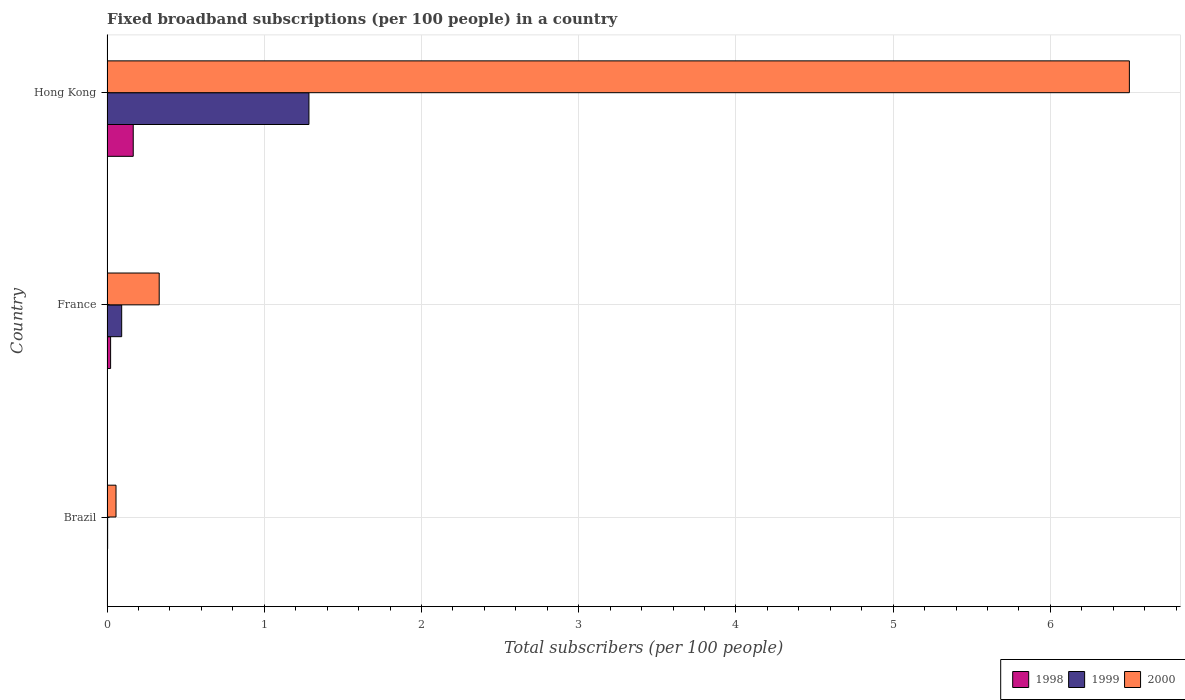Are the number of bars on each tick of the Y-axis equal?
Ensure brevity in your answer.  Yes. In how many cases, is the number of bars for a given country not equal to the number of legend labels?
Make the answer very short. 0. What is the number of broadband subscriptions in 2000 in France?
Make the answer very short. 0.33. Across all countries, what is the maximum number of broadband subscriptions in 1998?
Provide a succinct answer. 0.17. Across all countries, what is the minimum number of broadband subscriptions in 2000?
Provide a short and direct response. 0.06. In which country was the number of broadband subscriptions in 1999 maximum?
Your response must be concise. Hong Kong. In which country was the number of broadband subscriptions in 2000 minimum?
Your answer should be very brief. Brazil. What is the total number of broadband subscriptions in 1998 in the graph?
Your answer should be compact. 0.19. What is the difference between the number of broadband subscriptions in 1998 in France and that in Hong Kong?
Make the answer very short. -0.14. What is the difference between the number of broadband subscriptions in 2000 in Hong Kong and the number of broadband subscriptions in 1998 in France?
Your response must be concise. 6.48. What is the average number of broadband subscriptions in 1998 per country?
Make the answer very short. 0.06. What is the difference between the number of broadband subscriptions in 1998 and number of broadband subscriptions in 2000 in Hong Kong?
Your response must be concise. -6.34. In how many countries, is the number of broadband subscriptions in 1998 greater than 6 ?
Give a very brief answer. 0. What is the ratio of the number of broadband subscriptions in 1999 in Brazil to that in Hong Kong?
Give a very brief answer. 0. Is the number of broadband subscriptions in 1999 in Brazil less than that in Hong Kong?
Offer a very short reply. Yes. Is the difference between the number of broadband subscriptions in 1998 in Brazil and Hong Kong greater than the difference between the number of broadband subscriptions in 2000 in Brazil and Hong Kong?
Keep it short and to the point. Yes. What is the difference between the highest and the second highest number of broadband subscriptions in 2000?
Your answer should be very brief. 6.17. What is the difference between the highest and the lowest number of broadband subscriptions in 1998?
Your answer should be very brief. 0.17. Is the sum of the number of broadband subscriptions in 1998 in Brazil and France greater than the maximum number of broadband subscriptions in 2000 across all countries?
Your answer should be very brief. No. What does the 1st bar from the top in France represents?
Your answer should be very brief. 2000. What does the 3rd bar from the bottom in Hong Kong represents?
Offer a terse response. 2000. Is it the case that in every country, the sum of the number of broadband subscriptions in 1999 and number of broadband subscriptions in 2000 is greater than the number of broadband subscriptions in 1998?
Provide a succinct answer. Yes. Does the graph contain any zero values?
Your answer should be compact. No. Does the graph contain grids?
Provide a short and direct response. Yes. How many legend labels are there?
Offer a very short reply. 3. What is the title of the graph?
Keep it short and to the point. Fixed broadband subscriptions (per 100 people) in a country. What is the label or title of the X-axis?
Provide a succinct answer. Total subscribers (per 100 people). What is the label or title of the Y-axis?
Offer a very short reply. Country. What is the Total subscribers (per 100 people) in 1998 in Brazil?
Provide a short and direct response. 0. What is the Total subscribers (per 100 people) of 1999 in Brazil?
Keep it short and to the point. 0. What is the Total subscribers (per 100 people) of 2000 in Brazil?
Ensure brevity in your answer.  0.06. What is the Total subscribers (per 100 people) in 1998 in France?
Your response must be concise. 0.02. What is the Total subscribers (per 100 people) of 1999 in France?
Ensure brevity in your answer.  0.09. What is the Total subscribers (per 100 people) in 2000 in France?
Your response must be concise. 0.33. What is the Total subscribers (per 100 people) of 1998 in Hong Kong?
Give a very brief answer. 0.17. What is the Total subscribers (per 100 people) in 1999 in Hong Kong?
Provide a short and direct response. 1.28. What is the Total subscribers (per 100 people) of 2000 in Hong Kong?
Ensure brevity in your answer.  6.5. Across all countries, what is the maximum Total subscribers (per 100 people) of 1998?
Give a very brief answer. 0.17. Across all countries, what is the maximum Total subscribers (per 100 people) of 1999?
Offer a very short reply. 1.28. Across all countries, what is the maximum Total subscribers (per 100 people) of 2000?
Ensure brevity in your answer.  6.5. Across all countries, what is the minimum Total subscribers (per 100 people) of 1998?
Offer a terse response. 0. Across all countries, what is the minimum Total subscribers (per 100 people) of 1999?
Ensure brevity in your answer.  0. Across all countries, what is the minimum Total subscribers (per 100 people) in 2000?
Offer a terse response. 0.06. What is the total Total subscribers (per 100 people) in 1998 in the graph?
Ensure brevity in your answer.  0.19. What is the total Total subscribers (per 100 people) of 1999 in the graph?
Provide a succinct answer. 1.38. What is the total Total subscribers (per 100 people) in 2000 in the graph?
Make the answer very short. 6.89. What is the difference between the Total subscribers (per 100 people) of 1998 in Brazil and that in France?
Make the answer very short. -0.02. What is the difference between the Total subscribers (per 100 people) of 1999 in Brazil and that in France?
Provide a succinct answer. -0.09. What is the difference between the Total subscribers (per 100 people) in 2000 in Brazil and that in France?
Your response must be concise. -0.27. What is the difference between the Total subscribers (per 100 people) of 1998 in Brazil and that in Hong Kong?
Your answer should be very brief. -0.17. What is the difference between the Total subscribers (per 100 people) of 1999 in Brazil and that in Hong Kong?
Offer a terse response. -1.28. What is the difference between the Total subscribers (per 100 people) of 2000 in Brazil and that in Hong Kong?
Your answer should be very brief. -6.45. What is the difference between the Total subscribers (per 100 people) of 1998 in France and that in Hong Kong?
Make the answer very short. -0.14. What is the difference between the Total subscribers (per 100 people) of 1999 in France and that in Hong Kong?
Your response must be concise. -1.19. What is the difference between the Total subscribers (per 100 people) in 2000 in France and that in Hong Kong?
Your answer should be very brief. -6.17. What is the difference between the Total subscribers (per 100 people) in 1998 in Brazil and the Total subscribers (per 100 people) in 1999 in France?
Give a very brief answer. -0.09. What is the difference between the Total subscribers (per 100 people) in 1998 in Brazil and the Total subscribers (per 100 people) in 2000 in France?
Your response must be concise. -0.33. What is the difference between the Total subscribers (per 100 people) in 1999 in Brazil and the Total subscribers (per 100 people) in 2000 in France?
Your response must be concise. -0.33. What is the difference between the Total subscribers (per 100 people) of 1998 in Brazil and the Total subscribers (per 100 people) of 1999 in Hong Kong?
Provide a succinct answer. -1.28. What is the difference between the Total subscribers (per 100 people) in 1998 in Brazil and the Total subscribers (per 100 people) in 2000 in Hong Kong?
Your response must be concise. -6.5. What is the difference between the Total subscribers (per 100 people) in 1999 in Brazil and the Total subscribers (per 100 people) in 2000 in Hong Kong?
Your answer should be compact. -6.5. What is the difference between the Total subscribers (per 100 people) in 1998 in France and the Total subscribers (per 100 people) in 1999 in Hong Kong?
Make the answer very short. -1.26. What is the difference between the Total subscribers (per 100 people) in 1998 in France and the Total subscribers (per 100 people) in 2000 in Hong Kong?
Give a very brief answer. -6.48. What is the difference between the Total subscribers (per 100 people) of 1999 in France and the Total subscribers (per 100 people) of 2000 in Hong Kong?
Give a very brief answer. -6.41. What is the average Total subscribers (per 100 people) in 1998 per country?
Offer a terse response. 0.06. What is the average Total subscribers (per 100 people) of 1999 per country?
Keep it short and to the point. 0.46. What is the average Total subscribers (per 100 people) in 2000 per country?
Make the answer very short. 2.3. What is the difference between the Total subscribers (per 100 people) in 1998 and Total subscribers (per 100 people) in 1999 in Brazil?
Offer a terse response. -0. What is the difference between the Total subscribers (per 100 people) of 1998 and Total subscribers (per 100 people) of 2000 in Brazil?
Keep it short and to the point. -0.06. What is the difference between the Total subscribers (per 100 people) in 1999 and Total subscribers (per 100 people) in 2000 in Brazil?
Your response must be concise. -0.05. What is the difference between the Total subscribers (per 100 people) of 1998 and Total subscribers (per 100 people) of 1999 in France?
Your answer should be very brief. -0.07. What is the difference between the Total subscribers (per 100 people) of 1998 and Total subscribers (per 100 people) of 2000 in France?
Give a very brief answer. -0.31. What is the difference between the Total subscribers (per 100 people) in 1999 and Total subscribers (per 100 people) in 2000 in France?
Offer a terse response. -0.24. What is the difference between the Total subscribers (per 100 people) of 1998 and Total subscribers (per 100 people) of 1999 in Hong Kong?
Give a very brief answer. -1.12. What is the difference between the Total subscribers (per 100 people) in 1998 and Total subscribers (per 100 people) in 2000 in Hong Kong?
Ensure brevity in your answer.  -6.34. What is the difference between the Total subscribers (per 100 people) of 1999 and Total subscribers (per 100 people) of 2000 in Hong Kong?
Keep it short and to the point. -5.22. What is the ratio of the Total subscribers (per 100 people) of 1998 in Brazil to that in France?
Offer a terse response. 0.03. What is the ratio of the Total subscribers (per 100 people) of 1999 in Brazil to that in France?
Offer a very short reply. 0.04. What is the ratio of the Total subscribers (per 100 people) of 2000 in Brazil to that in France?
Keep it short and to the point. 0.17. What is the ratio of the Total subscribers (per 100 people) of 1998 in Brazil to that in Hong Kong?
Your response must be concise. 0. What is the ratio of the Total subscribers (per 100 people) of 1999 in Brazil to that in Hong Kong?
Your answer should be compact. 0. What is the ratio of the Total subscribers (per 100 people) of 2000 in Brazil to that in Hong Kong?
Keep it short and to the point. 0.01. What is the ratio of the Total subscribers (per 100 people) of 1998 in France to that in Hong Kong?
Provide a succinct answer. 0.14. What is the ratio of the Total subscribers (per 100 people) in 1999 in France to that in Hong Kong?
Offer a very short reply. 0.07. What is the ratio of the Total subscribers (per 100 people) in 2000 in France to that in Hong Kong?
Offer a terse response. 0.05. What is the difference between the highest and the second highest Total subscribers (per 100 people) of 1998?
Provide a short and direct response. 0.14. What is the difference between the highest and the second highest Total subscribers (per 100 people) in 1999?
Offer a very short reply. 1.19. What is the difference between the highest and the second highest Total subscribers (per 100 people) of 2000?
Provide a short and direct response. 6.17. What is the difference between the highest and the lowest Total subscribers (per 100 people) in 1998?
Make the answer very short. 0.17. What is the difference between the highest and the lowest Total subscribers (per 100 people) in 1999?
Your answer should be very brief. 1.28. What is the difference between the highest and the lowest Total subscribers (per 100 people) of 2000?
Your answer should be compact. 6.45. 